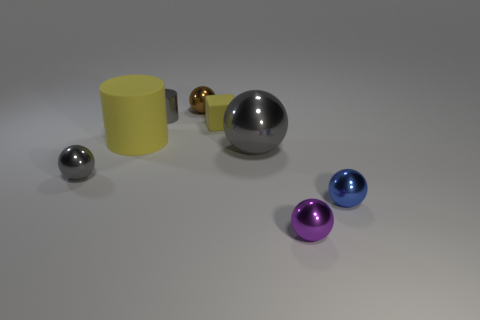What is the size of the yellow cylinder?
Keep it short and to the point. Large. What shape is the brown metal thing?
Your response must be concise. Sphere. There is a small cylinder that is on the left side of the small brown shiny thing; does it have the same color as the big ball?
Make the answer very short. Yes. There is a metal thing that is to the right of the shiny object in front of the tiny blue shiny ball; is there a object that is behind it?
Give a very brief answer. Yes. There is a yellow object right of the brown object; what is its material?
Provide a succinct answer. Rubber. What number of big things are either gray balls or purple shiny cubes?
Your response must be concise. 1. Do the metal thing in front of the blue thing and the large gray metal object have the same size?
Offer a very short reply. No. How many other things are the same color as the shiny cylinder?
Your answer should be very brief. 2. What material is the cube?
Provide a short and direct response. Rubber. What is the material of the object that is both on the right side of the brown shiny sphere and behind the yellow rubber cylinder?
Offer a terse response. Rubber. 